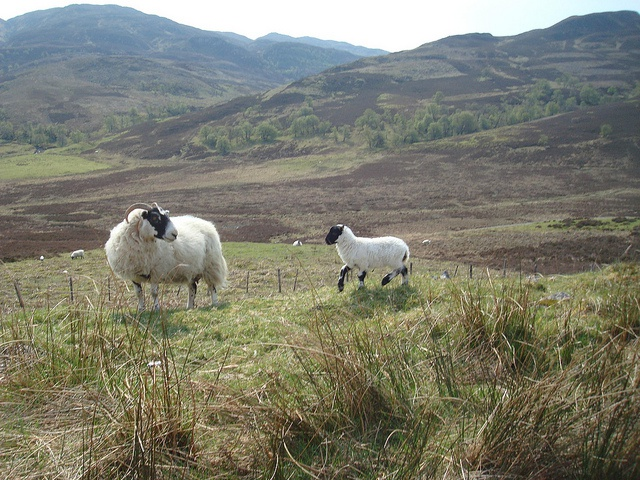Describe the objects in this image and their specific colors. I can see sheep in white, gray, darkgray, and ivory tones and sheep in white, darkgray, lightgray, black, and gray tones in this image. 